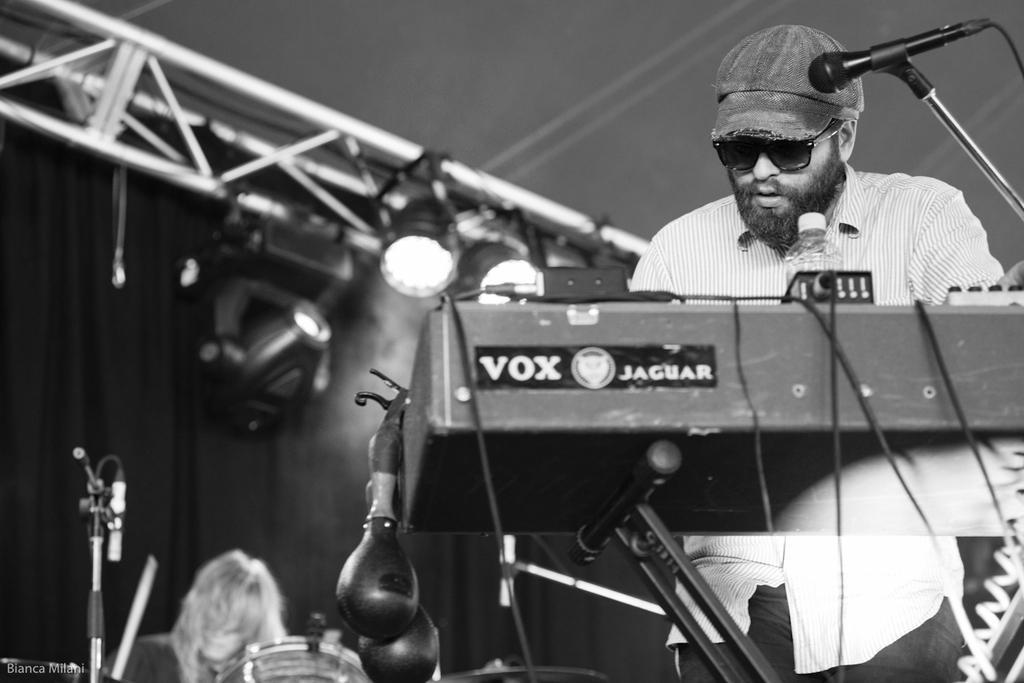How would you summarize this image in a sentence or two? In this picture I can see there is a man standing, he has a piano in front of him, there is a microphone on to right side and there is another person in the backdrop playing the drum set and there is a curtain in the backdrop and there are lights attached to the ceiling and the person playing the piano is having beard, mustache and he is wearing a cap and glasses. 